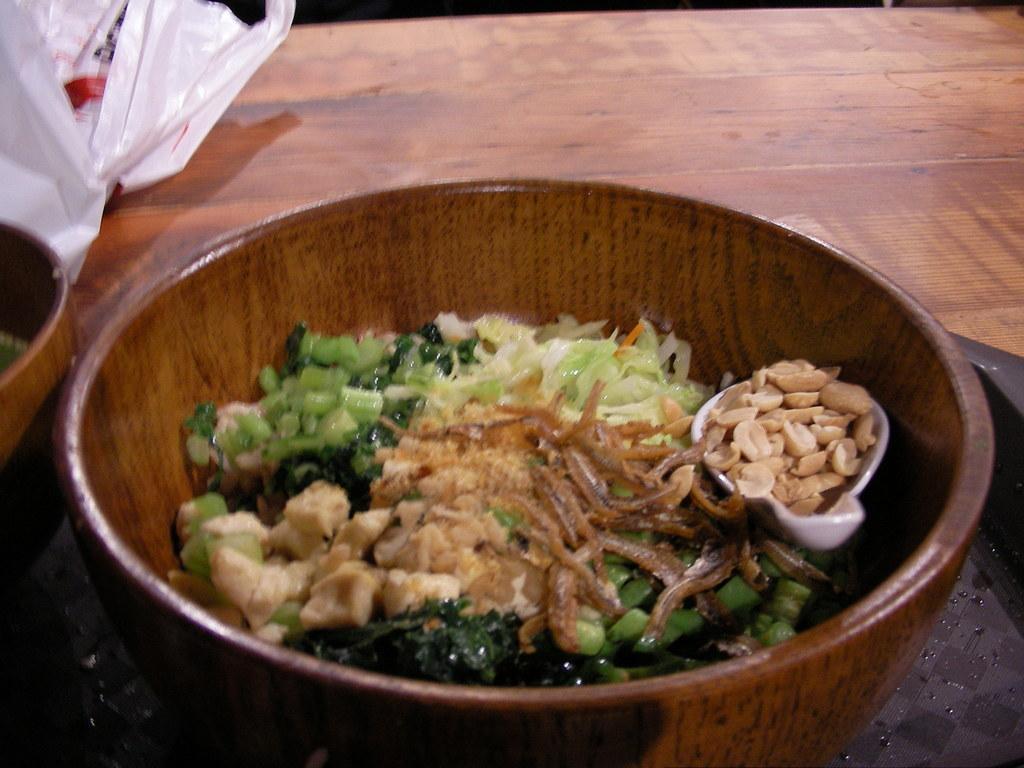Please provide a concise description of this image. We can see bowls,tray and cover on the table. 